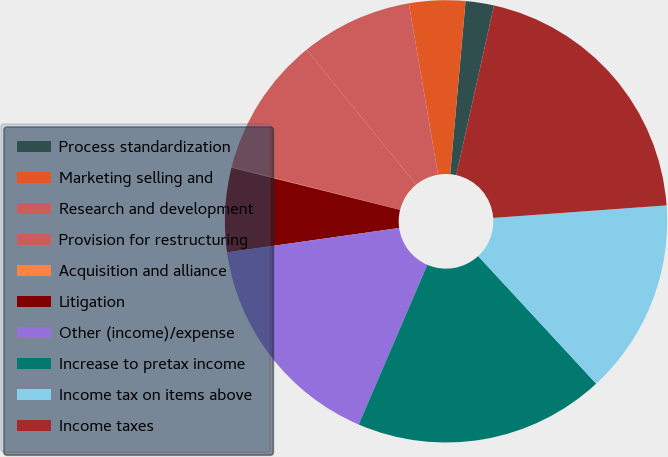<chart> <loc_0><loc_0><loc_500><loc_500><pie_chart><fcel>Process standardization<fcel>Marketing selling and<fcel>Research and development<fcel>Provision for restructuring<fcel>Acquisition and alliance<fcel>Litigation<fcel>Other (income)/expense<fcel>Increase to pretax income<fcel>Income tax on items above<fcel>Income taxes<nl><fcel>2.07%<fcel>4.1%<fcel>8.17%<fcel>10.2%<fcel>0.04%<fcel>6.14%<fcel>16.3%<fcel>18.34%<fcel>14.27%<fcel>20.37%<nl></chart> 